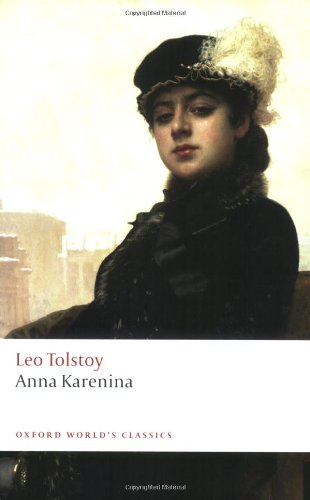What is the historical significance of the setting in 'Anna Karenina'? The setting of 'Anna Karenina' in the late 19th century Russia is crucial, reflecting the time of great social and political change. It provides backdrop to the personal dramas and critiques the socio-political landscape of that era, especially focusing on issues such as serfdom, the rising bourgeoisie, and the changing Russian society. 